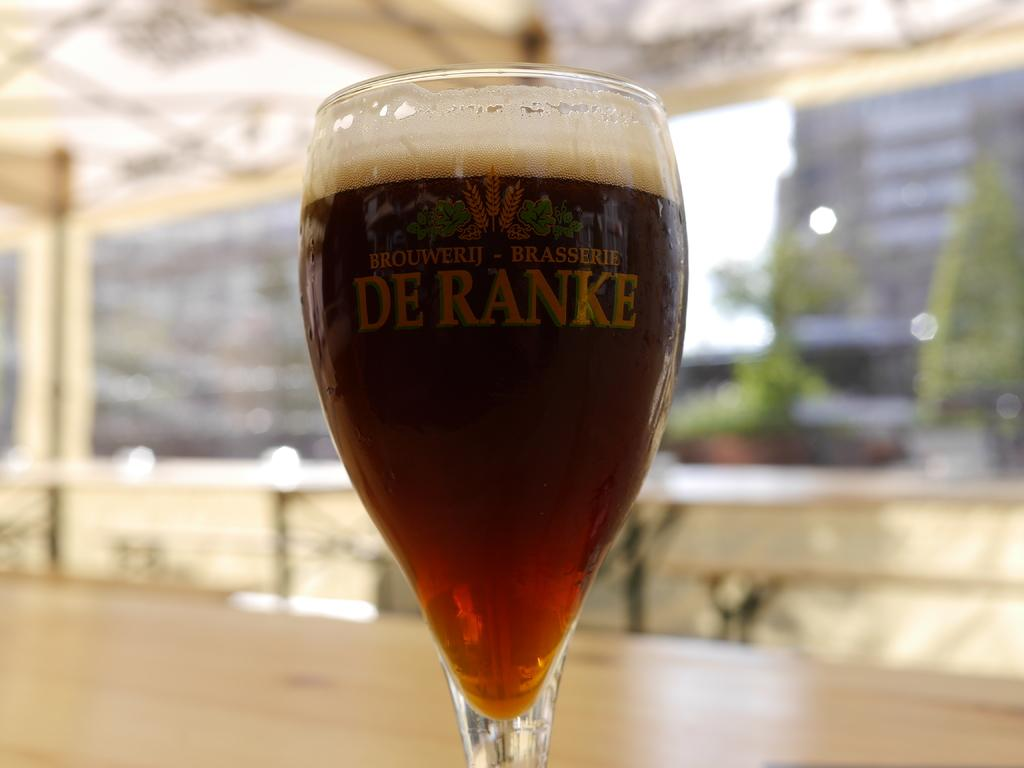<image>
Render a clear and concise summary of the photo. A glass with the words DE RANKE on it is full. 